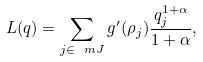Convert formula to latex. <formula><loc_0><loc_0><loc_500><loc_500>L ( q ) = \sum _ { j \in \ m J } g ^ { \prime } ( \rho _ { j } ) \frac { q _ { j } ^ { 1 + \alpha } } { 1 + \alpha } ,</formula> 